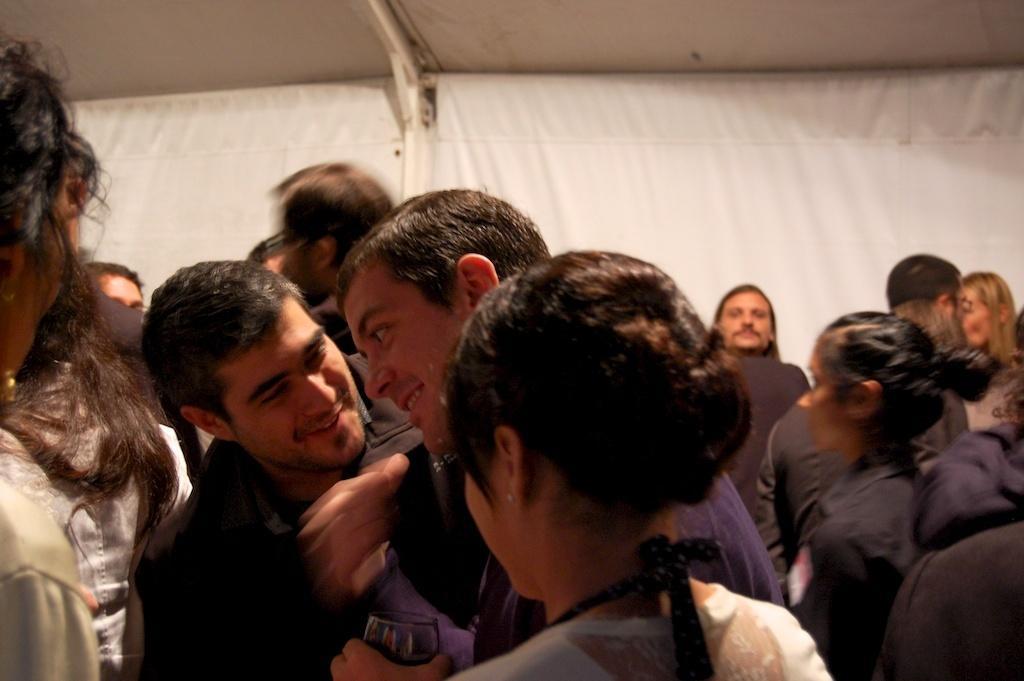Can you describe this image briefly? In this image we can see group of people. In the background we can see white color cloth. 